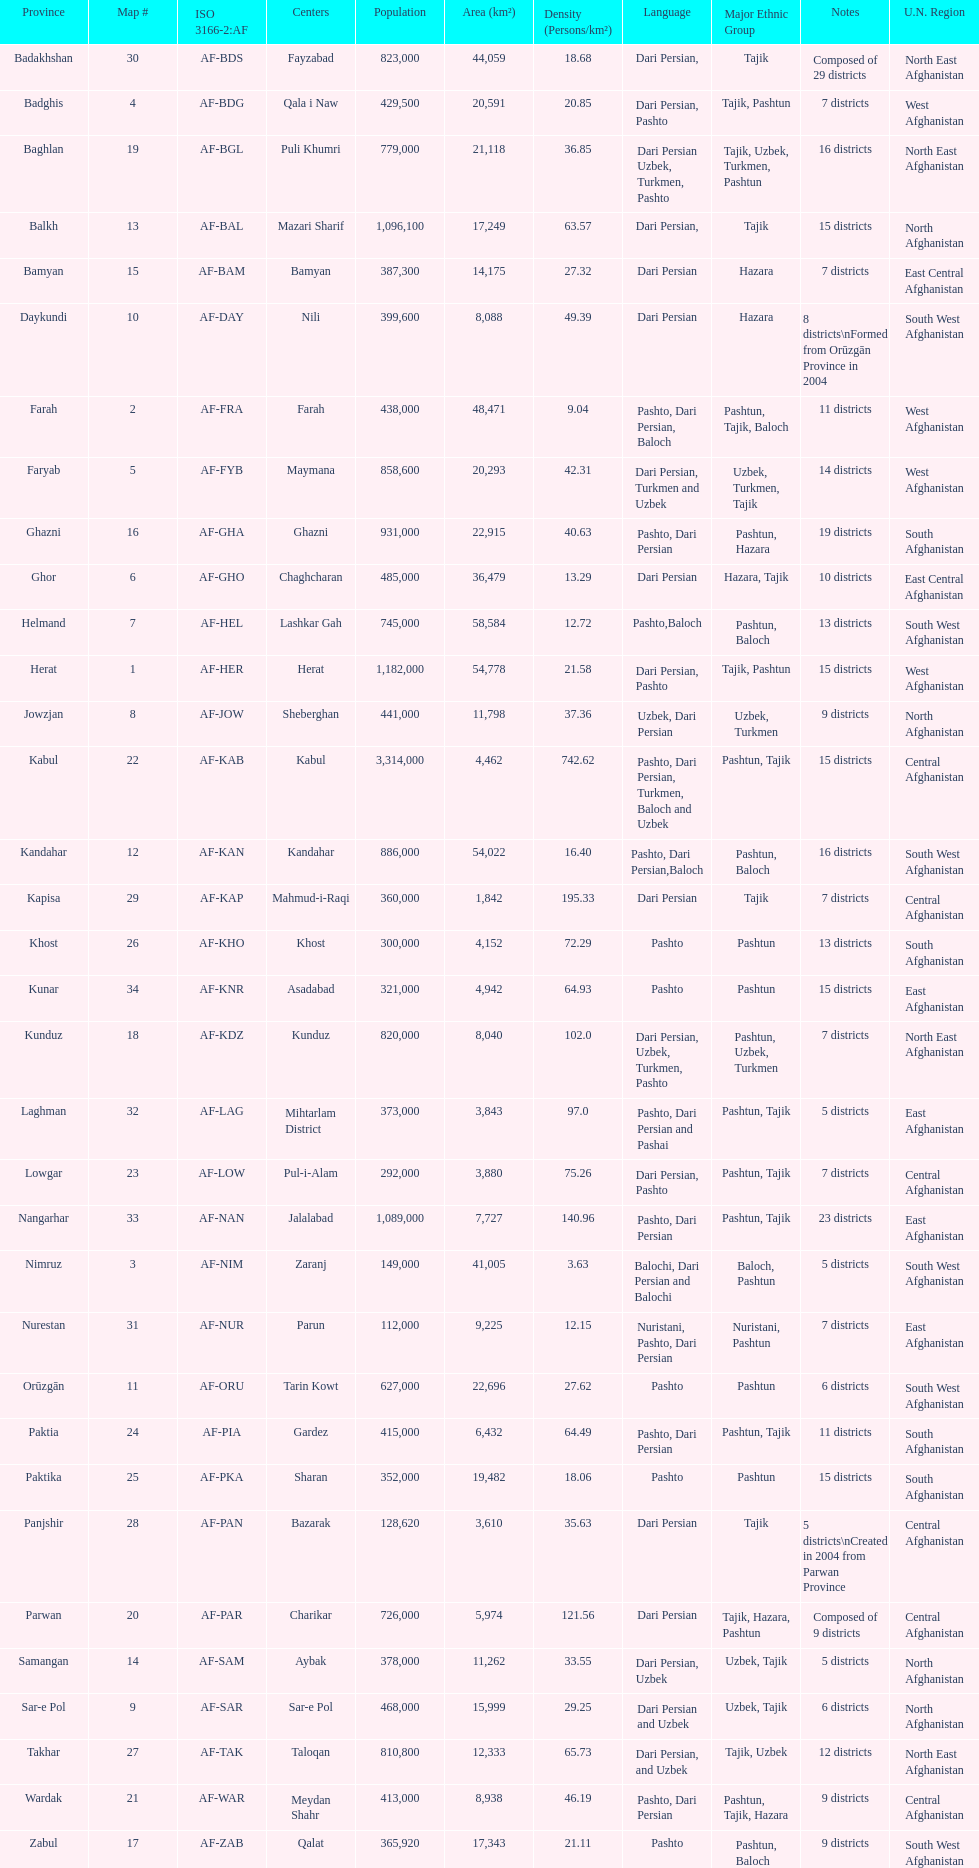How many districts are in the province of kunduz? 7. 